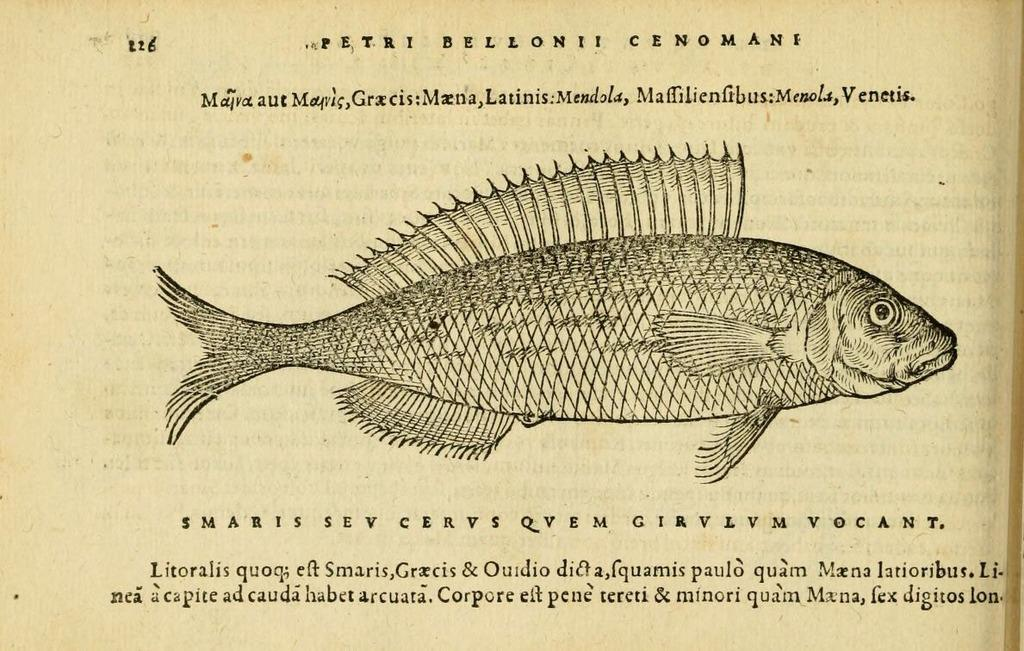What is the color of the paper in the image? The paper in the image is light brown in color. What is depicted on the paper? There is a diagram of a fish on the paper. What else can be seen on the paper besides the fish diagram? There are words and numbers visible on the paper. What type of science experiment is being conducted in the image? There is no indication of a science experiment in the image; it only shows a paper with a fish diagram, words, and numbers. 